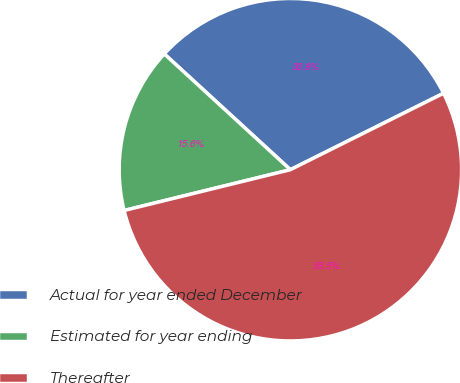<chart> <loc_0><loc_0><loc_500><loc_500><pie_chart><fcel>Actual for year ended December<fcel>Estimated for year ending<fcel>Thereafter<nl><fcel>30.81%<fcel>15.65%<fcel>53.54%<nl></chart> 